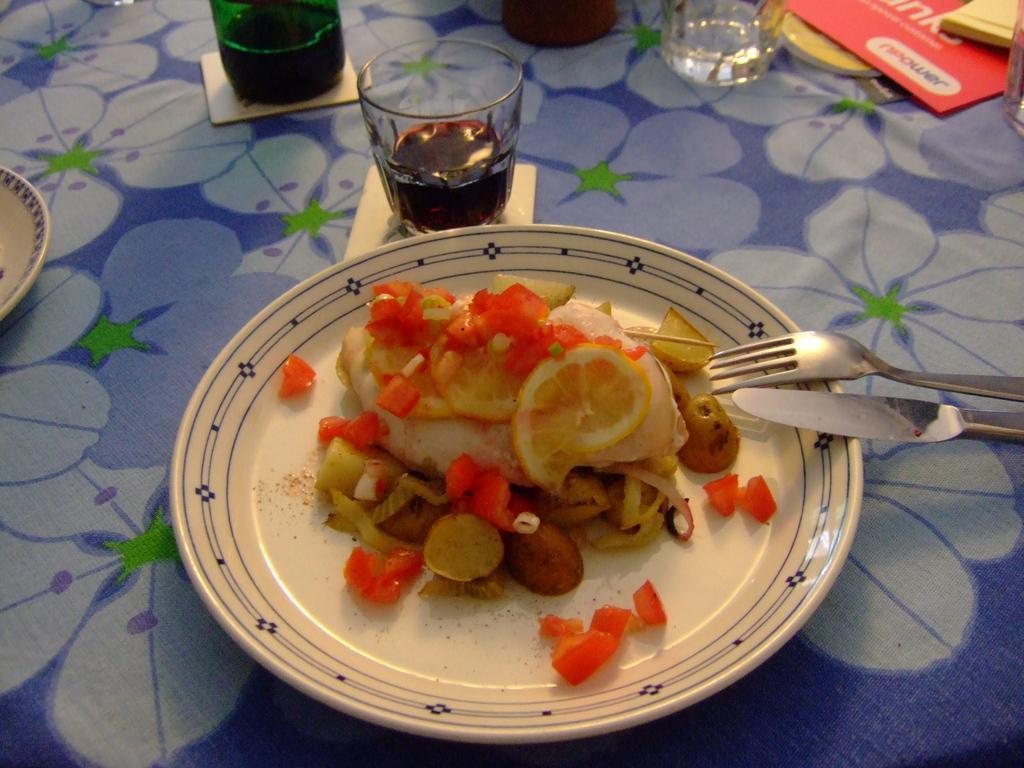Please provide a concise description of this image. This image consists of food which is on the plate in the center. On the right side there is a folk and there is a knife. At the top on the table there are glasses, papers and there is a plate on the left side. 